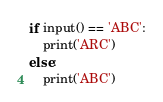Convert code to text. <code><loc_0><loc_0><loc_500><loc_500><_Python_>if input() == 'ABC':
    print('ARC')
else:
    print('ABC')</code> 